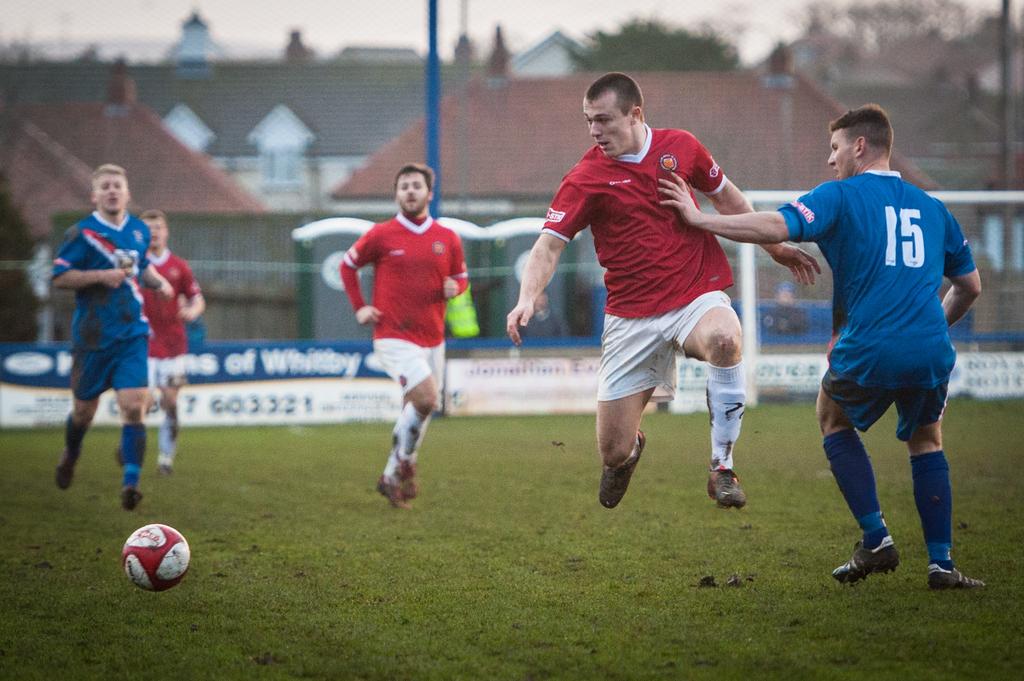What number is on the back of the player in blue?
Make the answer very short. 15. 